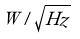<formula> <loc_0><loc_0><loc_500><loc_500>W / \sqrt { H z }</formula> 